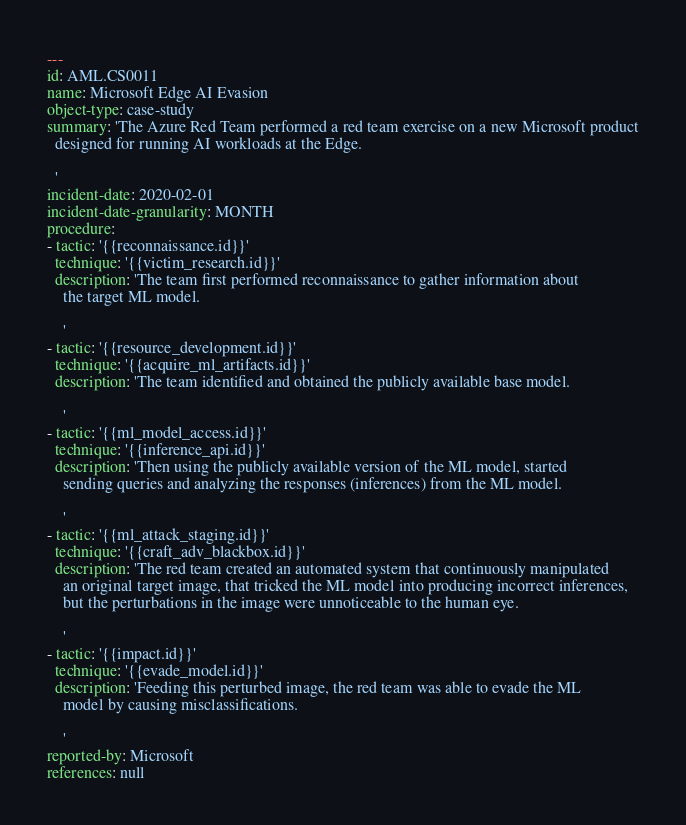<code> <loc_0><loc_0><loc_500><loc_500><_YAML_>---
id: AML.CS0011
name: Microsoft Edge AI Evasion
object-type: case-study
summary: 'The Azure Red Team performed a red team exercise on a new Microsoft product
  designed for running AI workloads at the Edge.

  '
incident-date: 2020-02-01
incident-date-granularity: MONTH
procedure:
- tactic: '{{reconnaissance.id}}'
  technique: '{{victim_research.id}}'
  description: 'The team first performed reconnaissance to gather information about
    the target ML model.

    '
- tactic: '{{resource_development.id}}'
  technique: '{{acquire_ml_artifacts.id}}'
  description: 'The team identified and obtained the publicly available base model.

    '
- tactic: '{{ml_model_access.id}}'
  technique: '{{inference_api.id}}'
  description: 'Then using the publicly available version of the ML model, started
    sending queries and analyzing the responses (inferences) from the ML model.

    '
- tactic: '{{ml_attack_staging.id}}'
  technique: '{{craft_adv_blackbox.id}}'
  description: 'The red team created an automated system that continuously manipulated
    an original target image, that tricked the ML model into producing incorrect inferences,
    but the perturbations in the image were unnoticeable to the human eye.

    '
- tactic: '{{impact.id}}'
  technique: '{{evade_model.id}}'
  description: 'Feeding this perturbed image, the red team was able to evade the ML
    model by causing misclassifications.

    '
reported-by: Microsoft
references: null
</code> 